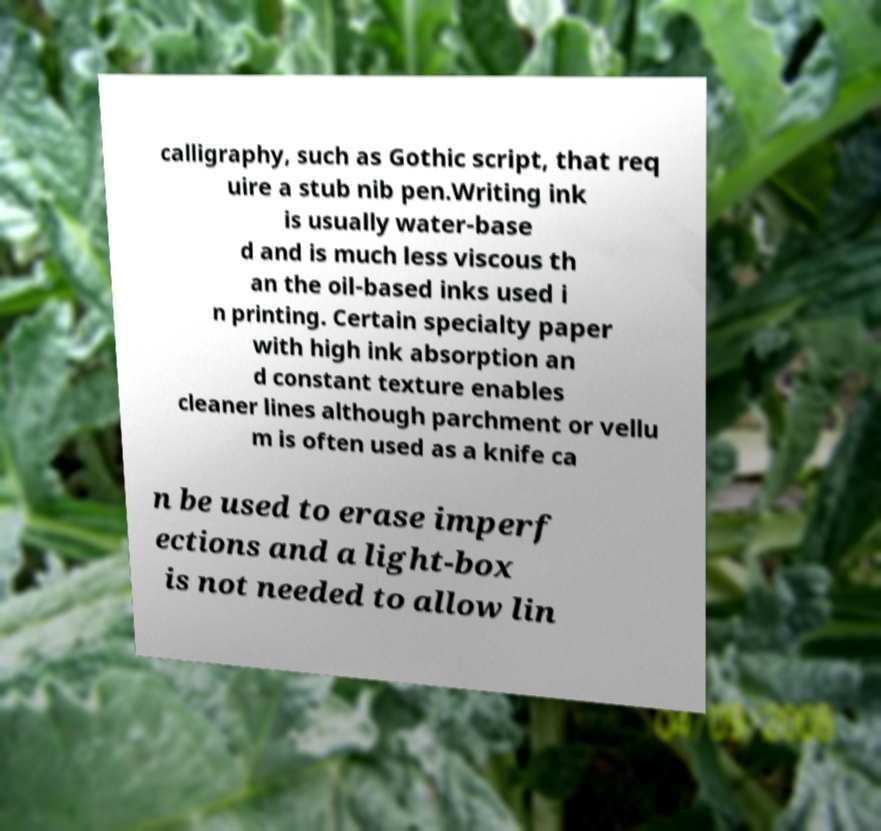What messages or text are displayed in this image? I need them in a readable, typed format. calligraphy, such as Gothic script, that req uire a stub nib pen.Writing ink is usually water-base d and is much less viscous th an the oil-based inks used i n printing. Certain specialty paper with high ink absorption an d constant texture enables cleaner lines although parchment or vellu m is often used as a knife ca n be used to erase imperf ections and a light-box is not needed to allow lin 